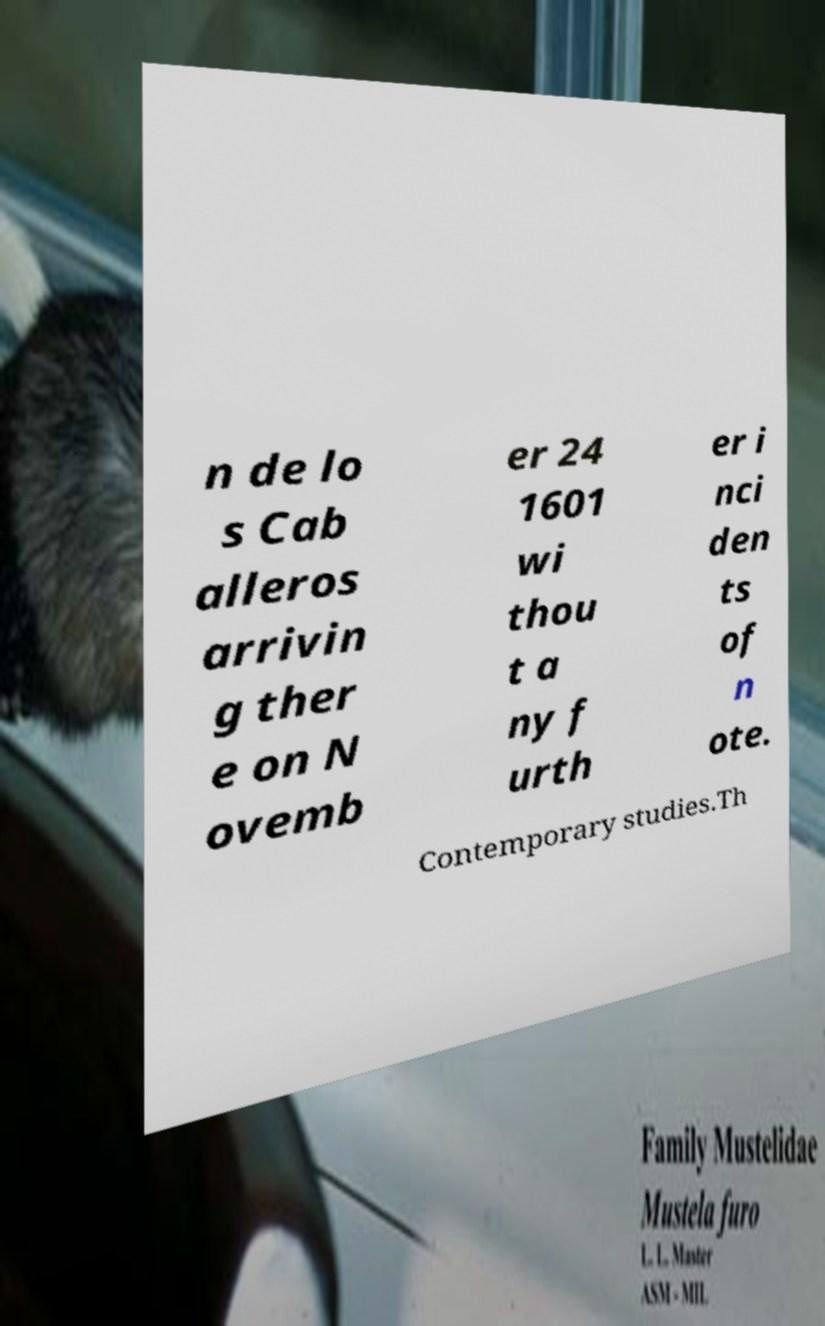Could you assist in decoding the text presented in this image and type it out clearly? n de lo s Cab alleros arrivin g ther e on N ovemb er 24 1601 wi thou t a ny f urth er i nci den ts of n ote. Contemporary studies.Th 